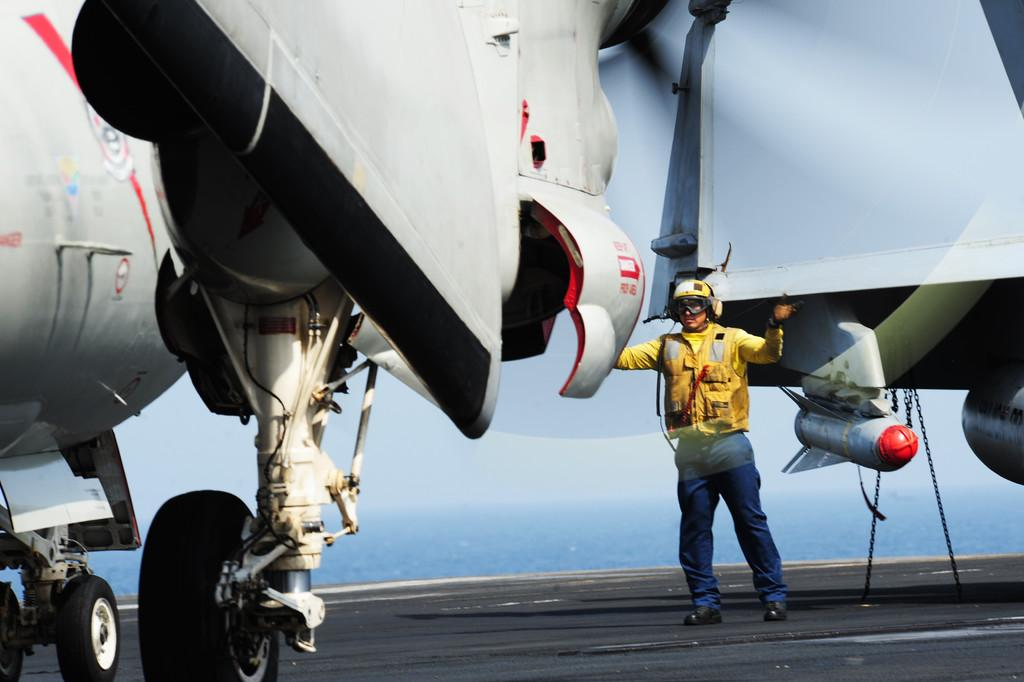What is the main subject of the picture? The main subject of the picture is an airplane. What feature of the airplane is mentioned in the facts? The airplane has wheels, which are fixed to the airplane. Who is present in the image besides the airplane? There is a man standing near the airplane. What is the man wearing? The man is wearing a yellow dress and a helmet. What can be seen in the background of the image? The sky is visible in the background of the image. How many bears are visible in the image? There are no bears present in the image. What type of shoe is the man wearing in the image? The man is not wearing any shoes in the image; he is wearing a yellow dress and a helmet. 